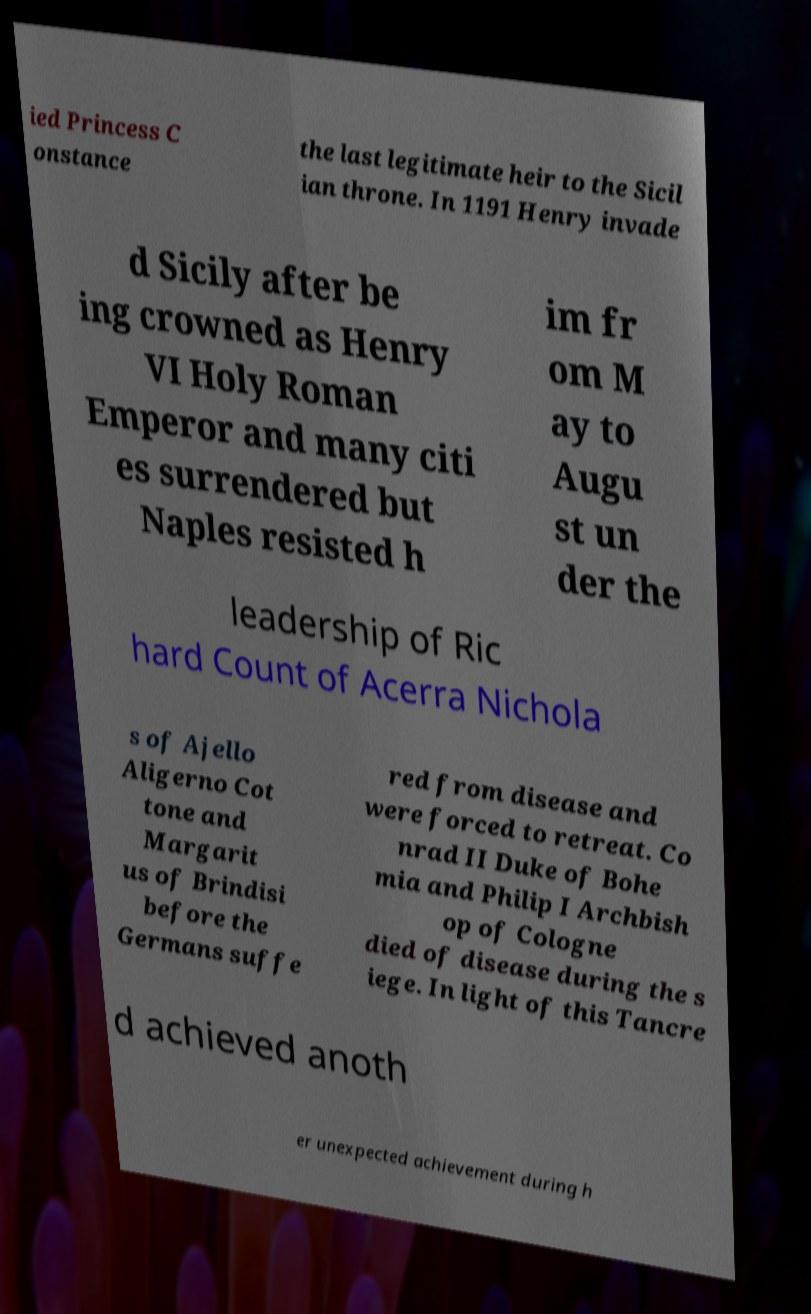Can you accurately transcribe the text from the provided image for me? ied Princess C onstance the last legitimate heir to the Sicil ian throne. In 1191 Henry invade d Sicily after be ing crowned as Henry VI Holy Roman Emperor and many citi es surrendered but Naples resisted h im fr om M ay to Augu st un der the leadership of Ric hard Count of Acerra Nichola s of Ajello Aligerno Cot tone and Margarit us of Brindisi before the Germans suffe red from disease and were forced to retreat. Co nrad II Duke of Bohe mia and Philip I Archbish op of Cologne died of disease during the s iege. In light of this Tancre d achieved anoth er unexpected achievement during h 